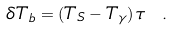Convert formula to latex. <formula><loc_0><loc_0><loc_500><loc_500>\delta T _ { b } = ( T _ { S } - T _ { \gamma } ) \, \tau \ .</formula> 